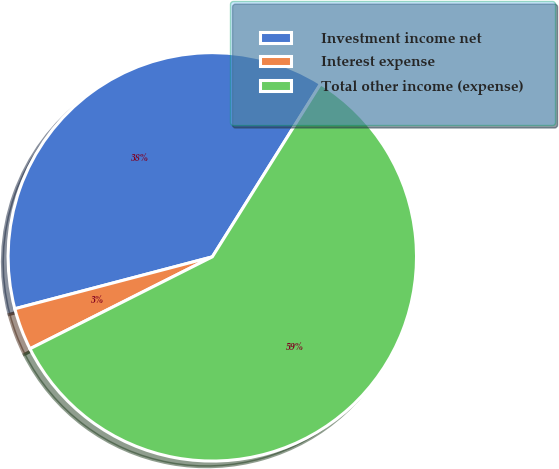Convert chart to OTSL. <chart><loc_0><loc_0><loc_500><loc_500><pie_chart><fcel>Investment income net<fcel>Interest expense<fcel>Total other income (expense)<nl><fcel>37.99%<fcel>3.34%<fcel>58.66%<nl></chart> 